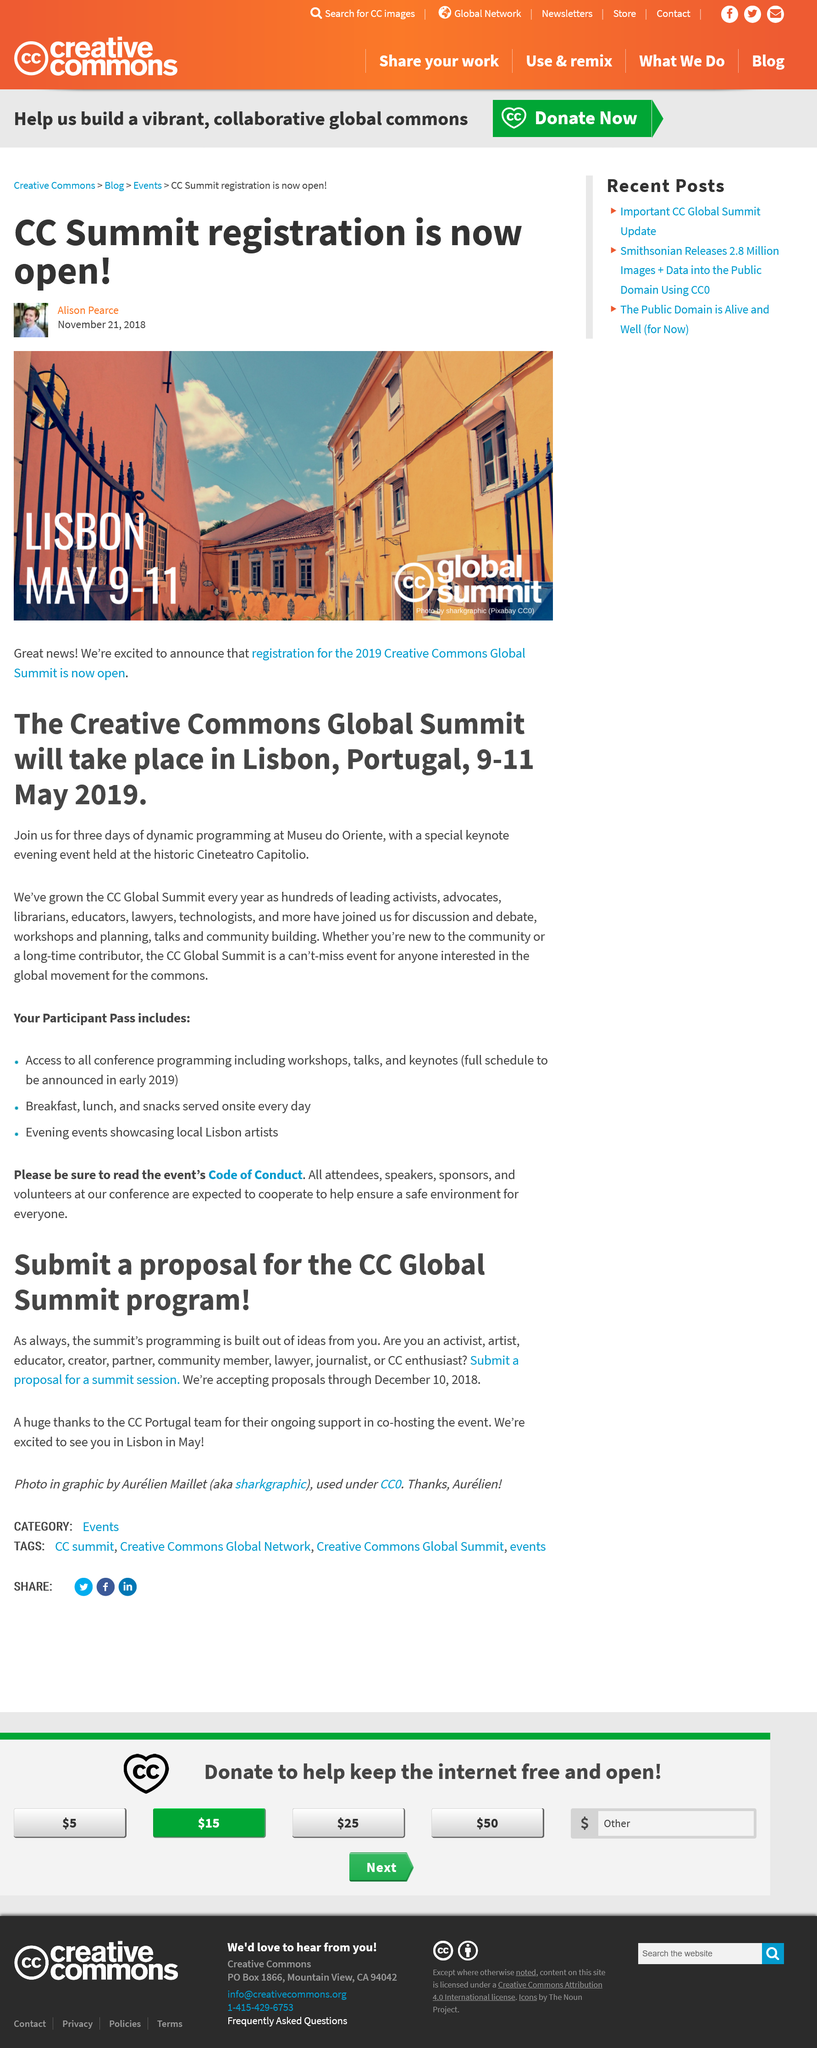List a handful of essential elements in this visual. The deadline date for proposal acceptances for a summit session for the CC Global Summit program is December 10, 2018. The CC Global Summit is an unmissable event for anyone interested in the global movement for the commons. The Creative Commons Global Summit will be held at Museu do Oriente in Lisbon, Portugal. The summit is held over three days, from the 9th to the 11th of May, inclusive. The CC Global Summit program is scheduled to be held in May. 